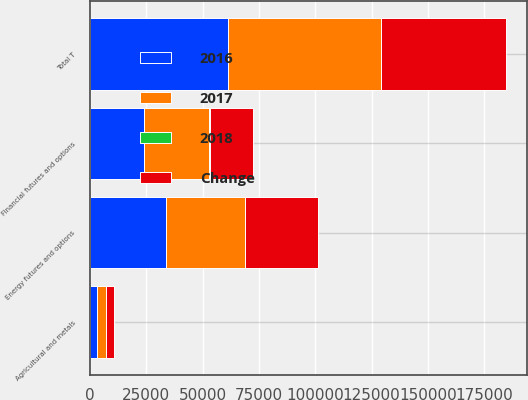Convert chart. <chart><loc_0><loc_0><loc_500><loc_500><stacked_bar_chart><ecel><fcel>Energy futures and options<fcel>Agricultural and metals<fcel>Financial futures and options<fcel>Total T<nl><fcel>2017<fcel>35019<fcel>3643<fcel>29061<fcel>67723<nl><fcel>2016<fcel>33906<fcel>3391<fcel>24025<fcel>61322<nl><fcel>2018<fcel>3<fcel>7<fcel>21<fcel>10<nl><fcel>Change<fcel>32096<fcel>3920<fcel>19413<fcel>55429<nl></chart> 